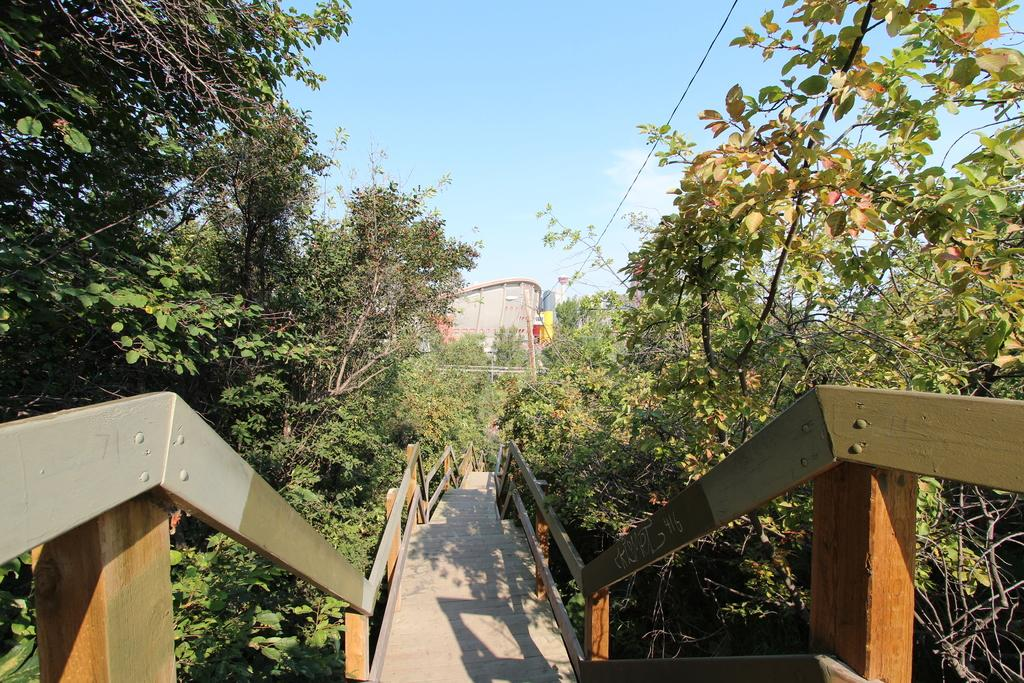What is located in the foreground of the image? There is a bridge, trees, wires, and a building in the foreground of the image. What can be seen in the sky in the image? The sky is visible at the top of the image. When was the image taken? The image was taken during the day. How does the mist affect the visibility of the building in the image? There is no mist present in the image, so it does not affect the visibility of the building. What is the reason for the quiver in the image? There is no quiver present in the image, so there is no reason for it. 